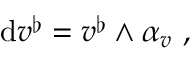<formula> <loc_0><loc_0><loc_500><loc_500>d v ^ { \flat } = v ^ { \flat } \wedge \alpha _ { v } \ ,</formula> 